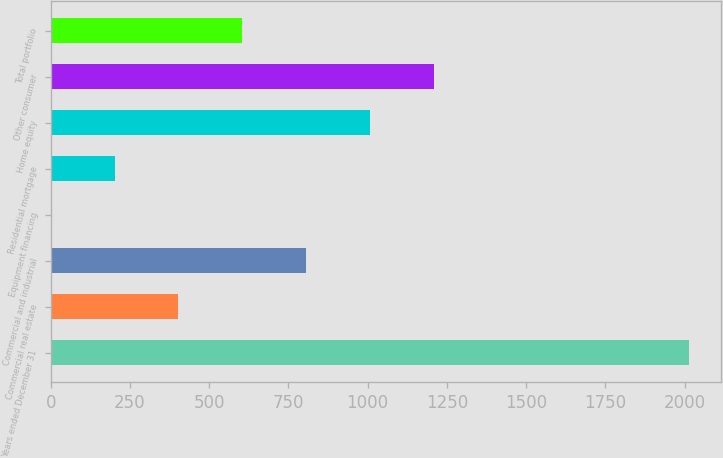<chart> <loc_0><loc_0><loc_500><loc_500><bar_chart><fcel>Years ended December 31<fcel>Commercial real estate<fcel>Commercial and industrial<fcel>Equipment financing<fcel>Residential mortgage<fcel>Home equity<fcel>Other consumer<fcel>Total portfolio<nl><fcel>2013<fcel>402.66<fcel>805.24<fcel>0.08<fcel>201.37<fcel>1006.53<fcel>1207.82<fcel>603.95<nl></chart> 